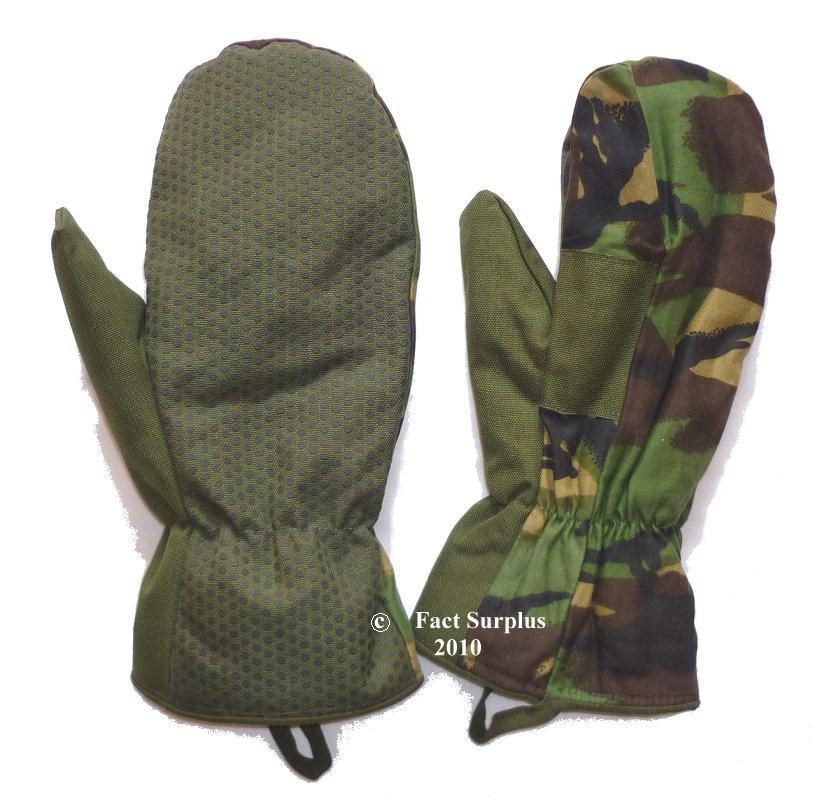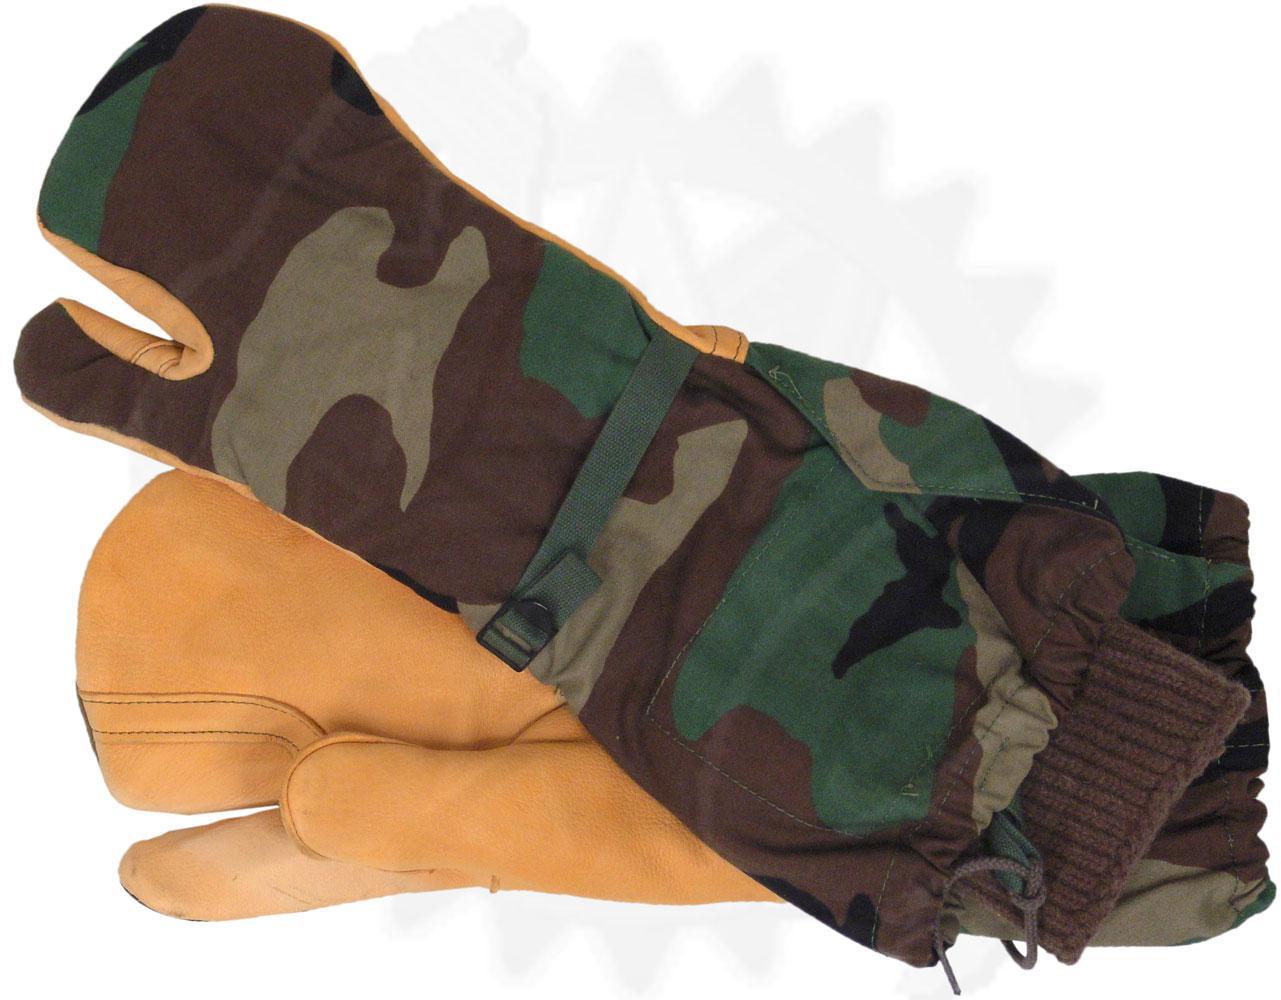The first image is the image on the left, the second image is the image on the right. Given the left and right images, does the statement "Two of the gloves can be seen to have a woodland camouflage pattern." hold true? Answer yes or no. Yes. The first image is the image on the left, the second image is the image on the right. For the images shown, is this caption "One image shows a pair of mittens with half-fingers exposed on one mitt only." true? Answer yes or no. No. 